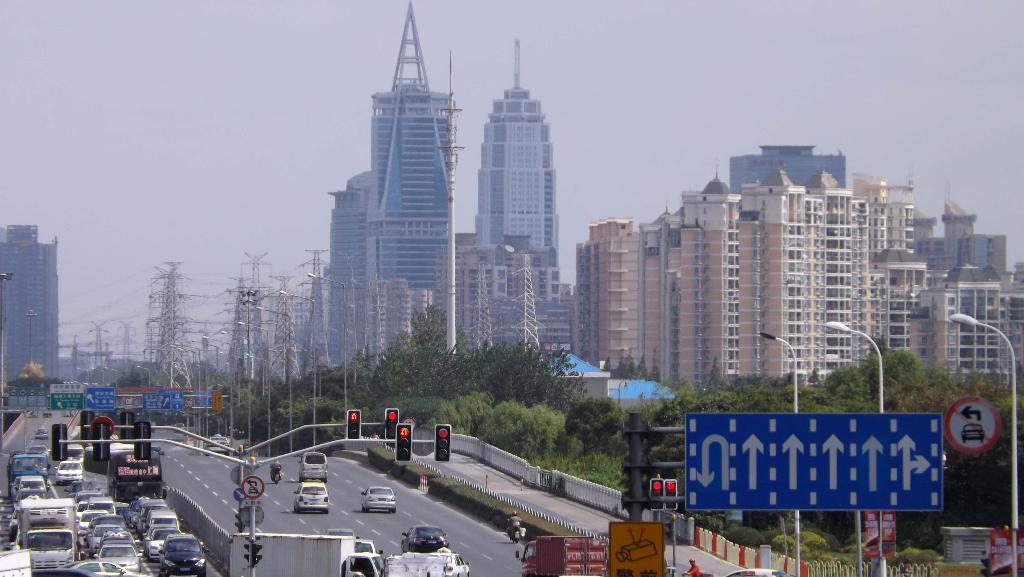What can be seen on the road in the image? There are vehicles on the road in the image. What helps regulate the flow of traffic in the image? There are traffic signals in the image. What provides information or directions in the image? There are sign boards in the image. What can be seen in the distance in the image? There are buildings and poles in the background of the image. What is visible above the buildings and poles in the image? The sky is visible in the background of the image. Are there any bushes visible in the image? There are no bushes present in the image. How does the roof of the building in the image protect against the rainstorm? There is no rainstorm present in the image, and the image does not show any roofs. 